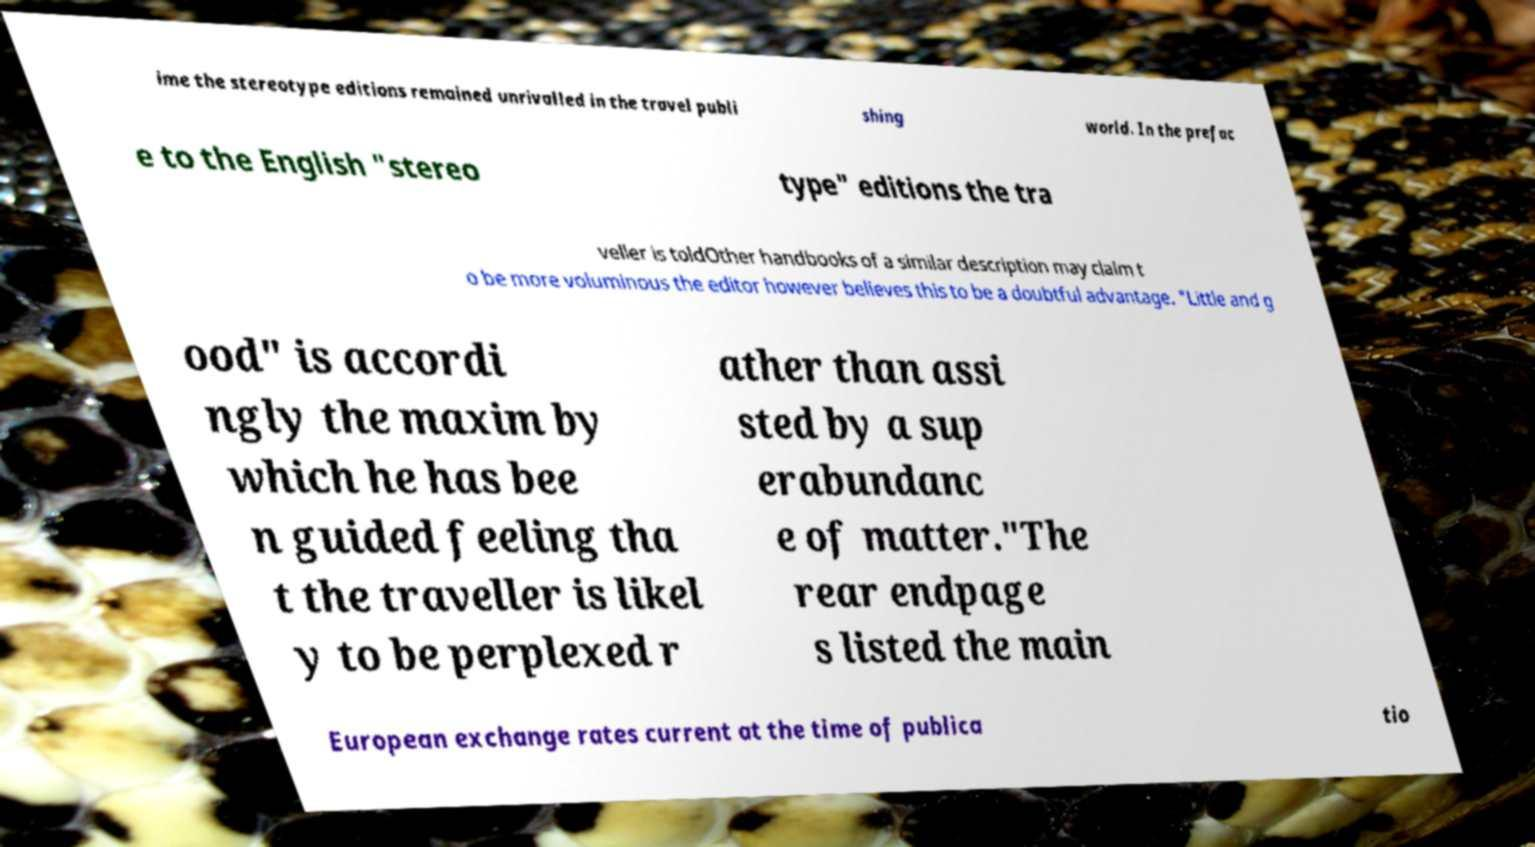Please identify and transcribe the text found in this image. ime the stereotype editions remained unrivalled in the travel publi shing world. In the prefac e to the English "stereo type" editions the tra veller is toldOther handbooks of a similar description may claim t o be more voluminous the editor however believes this to be a doubtful advantage. "Little and g ood" is accordi ngly the maxim by which he has bee n guided feeling tha t the traveller is likel y to be perplexed r ather than assi sted by a sup erabundanc e of matter."The rear endpage s listed the main European exchange rates current at the time of publica tio 